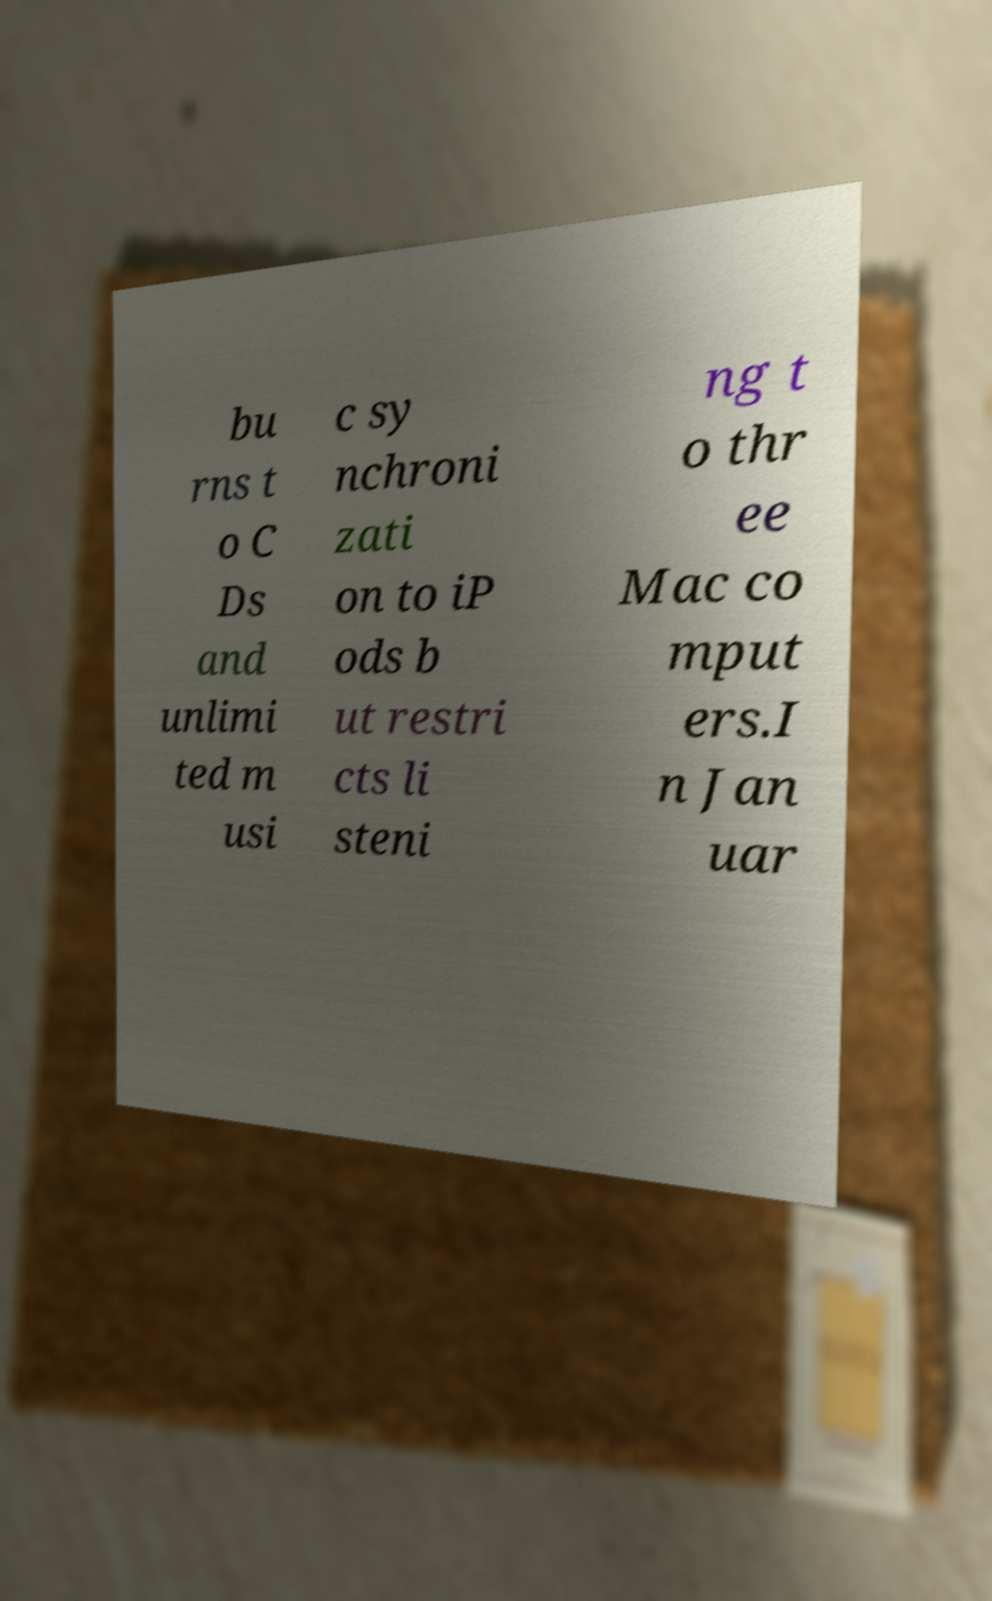Could you extract and type out the text from this image? bu rns t o C Ds and unlimi ted m usi c sy nchroni zati on to iP ods b ut restri cts li steni ng t o thr ee Mac co mput ers.I n Jan uar 